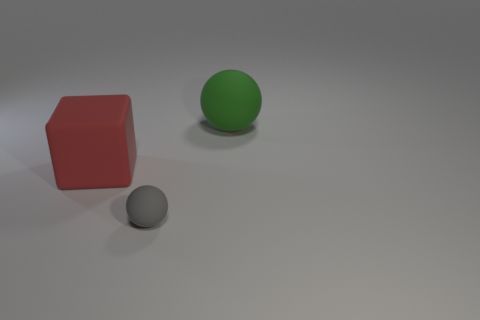Are there any yellow balls made of the same material as the tiny gray ball?
Your answer should be compact. No. There is a rubber sphere behind the red rubber block; does it have the same size as the red thing?
Keep it short and to the point. Yes. How many purple things are either tiny matte things or cubes?
Give a very brief answer. 0. There is a large red block in front of the large green sphere; what material is it?
Provide a short and direct response. Rubber. What number of matte things are to the left of the large matte object that is on the right side of the matte cube?
Your answer should be compact. 2. What number of large green matte things are the same shape as the gray thing?
Ensure brevity in your answer.  1. What number of tiny balls are there?
Your response must be concise. 1. There is a large matte object left of the big green thing; what color is it?
Offer a very short reply. Red. What is the color of the rubber ball in front of the matte sphere that is on the right side of the gray matte sphere?
Offer a very short reply. Gray. What color is the matte sphere that is the same size as the red rubber cube?
Ensure brevity in your answer.  Green. 